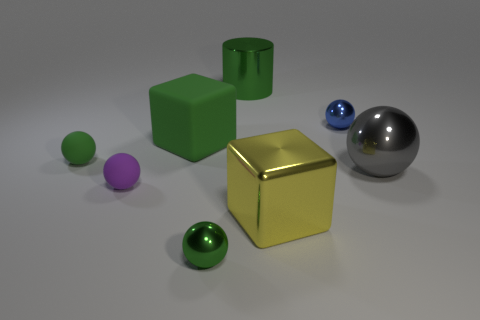What is the small thing right of the metallic cylinder made of?
Make the answer very short. Metal. Are there any large blocks of the same color as the large rubber object?
Your answer should be compact. No. What color is the shiny sphere that is the same size as the yellow thing?
Your answer should be very brief. Gray. What number of tiny objects are either rubber cylinders or rubber objects?
Provide a short and direct response. 2. Are there an equal number of purple matte balls that are behind the large green rubber thing and green cylinders that are in front of the small purple matte ball?
Ensure brevity in your answer.  Yes. What number of purple matte things are the same size as the blue shiny object?
Your answer should be very brief. 1. What number of green objects are big shiny objects or big rubber blocks?
Your response must be concise. 2. Are there an equal number of big rubber objects on the left side of the purple rubber object and green cubes?
Your answer should be compact. No. There is a green ball that is behind the big yellow block; how big is it?
Offer a very short reply. Small. How many yellow metal things are the same shape as the small green rubber object?
Your response must be concise. 0. 